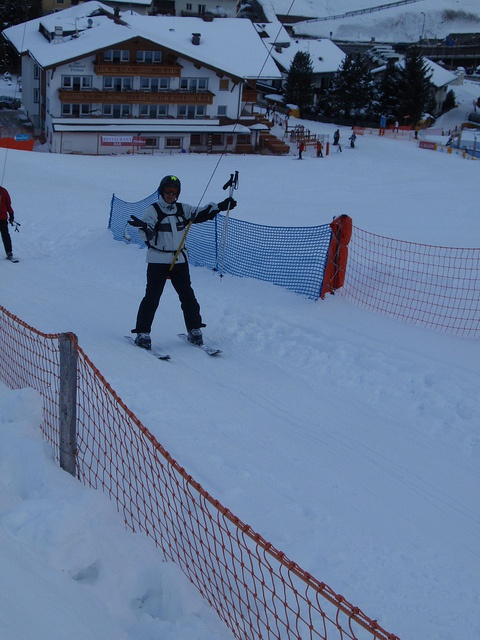Describe the objects in this image and their specific colors. I can see people in black, gray, and blue tones, people in black, maroon, navy, and gray tones, skis in black, gray, navy, and blue tones, people in black, navy, maroon, and purple tones, and people in black, navy, gray, and darkblue tones in this image. 